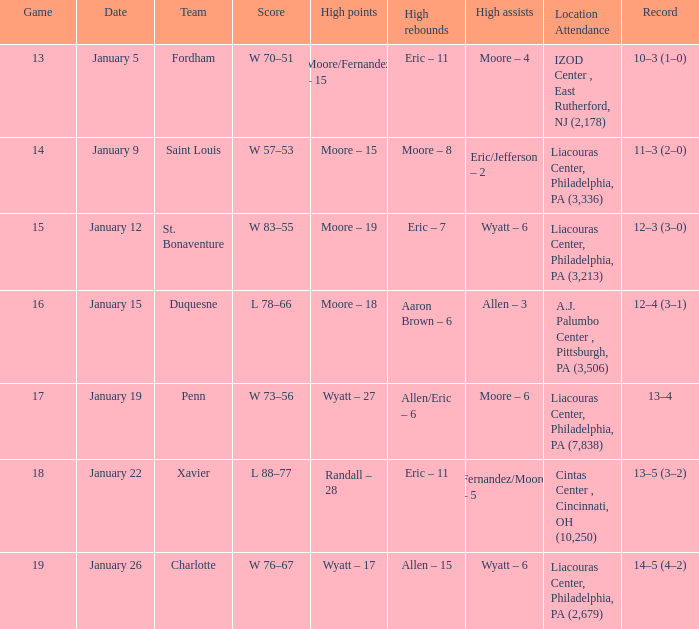Who had the most assists and how many did they have on January 5? Moore – 4. 